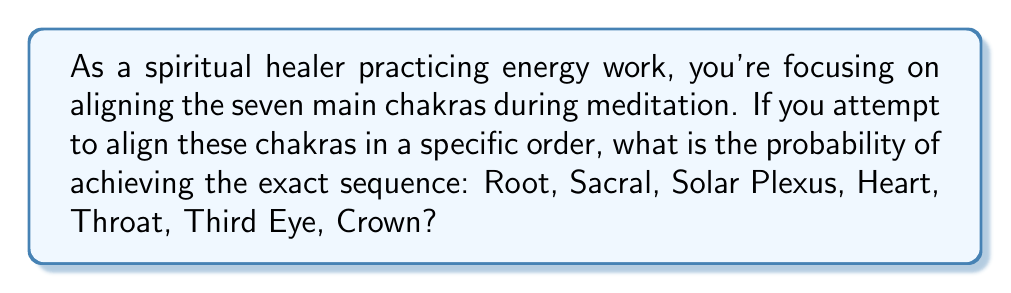Can you solve this math problem? To solve this probability problem, we need to consider the following:

1. There are 7 main chakras to be aligned.
2. We are looking for a specific order of alignment.
3. Each chakra can only be aligned once in the sequence.

This scenario is equivalent to arranging 7 distinct objects in a specific order, which is a permutation problem.

The total number of possible permutations for 7 distinct objects is:

$$ 7! = 7 \times 6 \times 5 \times 4 \times 3 \times 2 \times 1 = 5040 $$

Since we are looking for one specific permutation out of all possible permutations, the probability is:

$$ P(\text{specific order}) = \frac{\text{favorable outcomes}}{\text{total outcomes}} = \frac{1}{7!} = \frac{1}{5040} $$

To express this as a decimal:

$$ \frac{1}{5040} \approx 0.000198413 $$

Or as a percentage:

$$ 0.000198413 \times 100\% \approx 0.0198\% $$
Answer: The probability of aligning the seven main chakras in the exact sequence: Root, Sacral, Solar Plexus, Heart, Throat, Third Eye, Crown is $\frac{1}{5040}$ or approximately $0.0198\%$. 